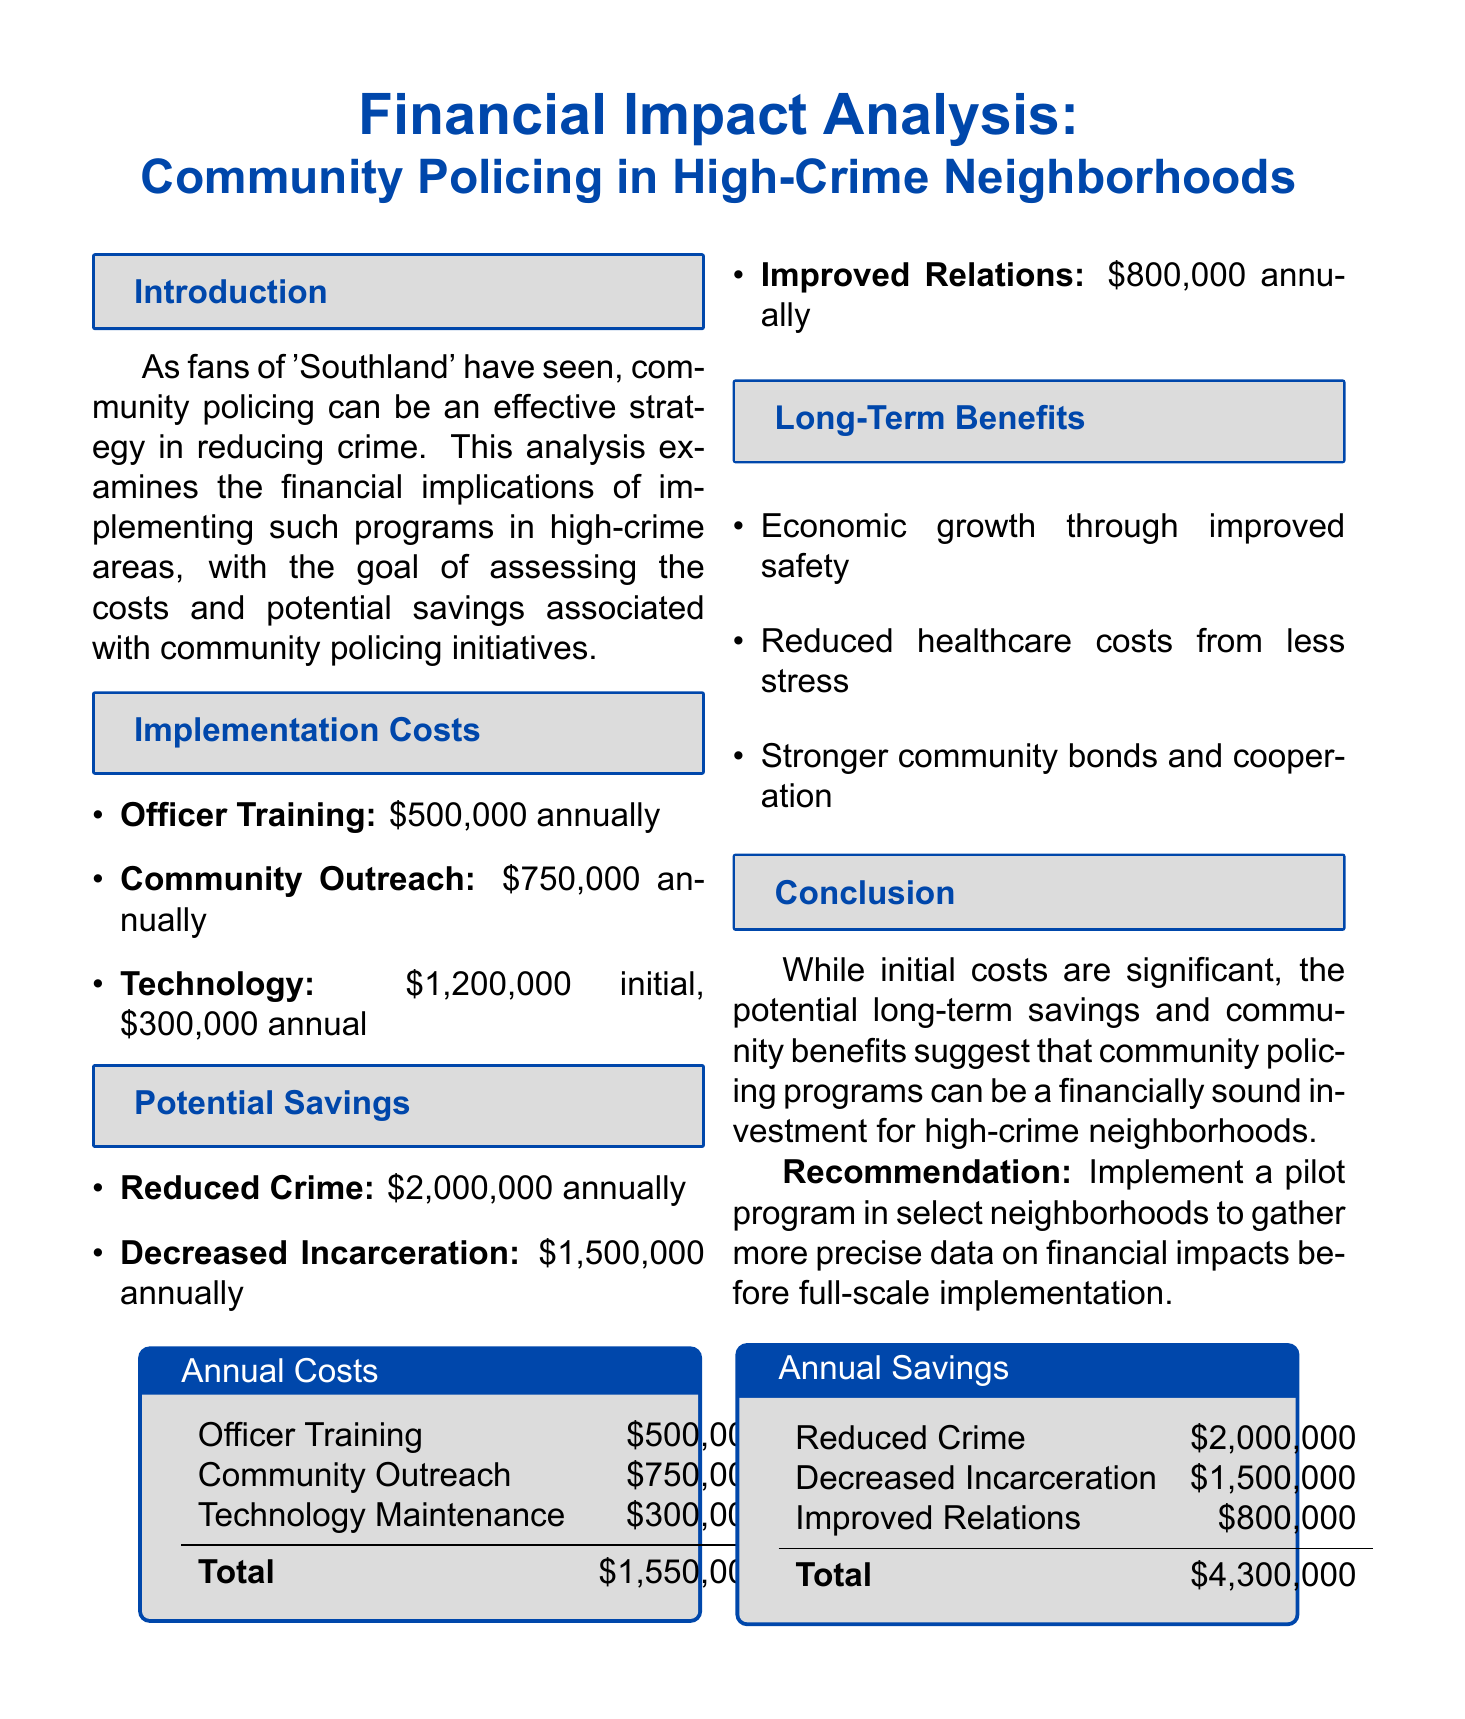What is the title of the report? The title of the report is stated at the beginning of the document.
Answer: Financial Impact Analysis: Community Policing in High-Crime Neighborhoods What are the estimated annual costs for Officer Training? The estimated annual cost for Officer Training is listed under Implementation Costs in the document.
Answer: $500,000 annually What is the estimated annual savings from Reduced Crime? The estimated annual savings from Reduced Crime is stated in the Potential Savings section of the document.
Answer: $2,000,000 annually What is the total estimated annual cost? The total estimated annual cost is the sum of all annual costs listed in the document.
Answer: $1,550,000 What long-term benefit relates to healthcare? Long-term benefits include reduced healthcare costs as a result of community policing.
Answer: Reduced stress and trauma in the community How much is estimated to be saved annually through Improved Community Relations? The amount saved annually through Improved Community Relations is provided in the Potential Savings section.
Answer: $800,000 annually What is the recommendation made in the conclusion? The recommendation is a key aspect of the report's conclusion and suggests a course of action.
Answer: Implement a pilot program in select neighborhoods What initial investment is required for Technology and Equipment? The initial investment required for Technology and Equipment is mentioned in the Implementation Costs.
Answer: $1,200,000 initial investment How much total savings can be expected annually? The total savings is the sum of all potential savings outlined in the Potential Savings section.
Answer: $4,300,000 